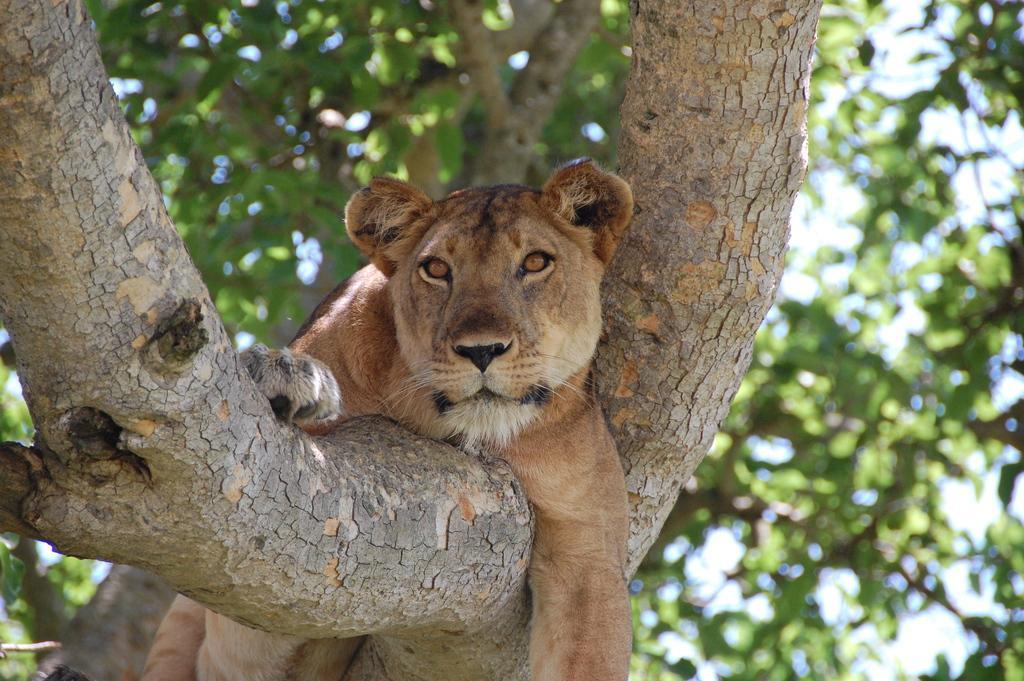How would you summarize this image in a sentence or two? In this image we can see a lion on the branch. In the background there are trees and sky. 